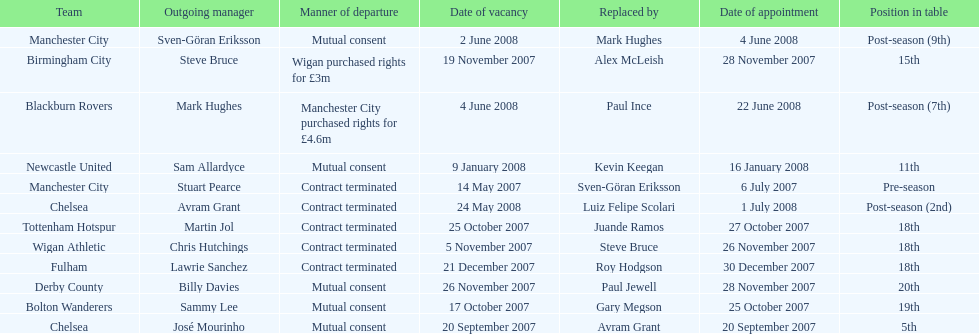Which outgoing manager was appointed the last? Mark Hughes. 